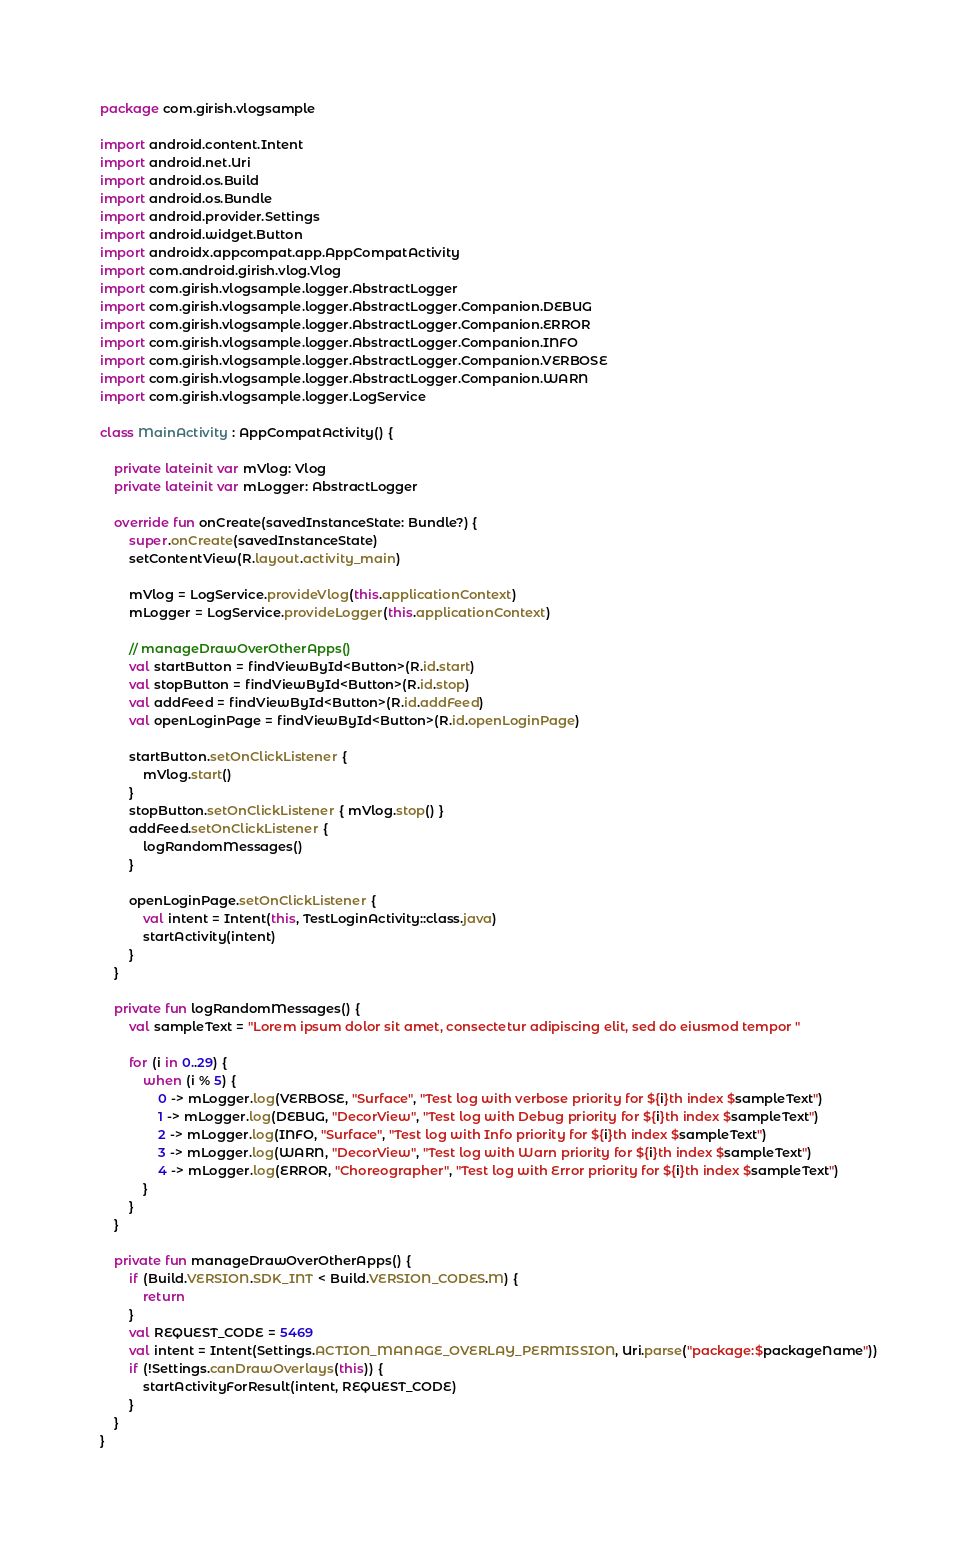<code> <loc_0><loc_0><loc_500><loc_500><_Kotlin_>package com.girish.vlogsample

import android.content.Intent
import android.net.Uri
import android.os.Build
import android.os.Bundle
import android.provider.Settings
import android.widget.Button
import androidx.appcompat.app.AppCompatActivity
import com.android.girish.vlog.Vlog
import com.girish.vlogsample.logger.AbstractLogger
import com.girish.vlogsample.logger.AbstractLogger.Companion.DEBUG
import com.girish.vlogsample.logger.AbstractLogger.Companion.ERROR
import com.girish.vlogsample.logger.AbstractLogger.Companion.INFO
import com.girish.vlogsample.logger.AbstractLogger.Companion.VERBOSE
import com.girish.vlogsample.logger.AbstractLogger.Companion.WARN
import com.girish.vlogsample.logger.LogService

class MainActivity : AppCompatActivity() {

    private lateinit var mVlog: Vlog
    private lateinit var mLogger: AbstractLogger

    override fun onCreate(savedInstanceState: Bundle?) {
        super.onCreate(savedInstanceState)
        setContentView(R.layout.activity_main)

        mVlog = LogService.provideVlog(this.applicationContext)
        mLogger = LogService.provideLogger(this.applicationContext)

        // manageDrawOverOtherApps()
        val startButton = findViewById<Button>(R.id.start)
        val stopButton = findViewById<Button>(R.id.stop)
        val addFeed = findViewById<Button>(R.id.addFeed)
        val openLoginPage = findViewById<Button>(R.id.openLoginPage)

        startButton.setOnClickListener {
            mVlog.start()
        }
        stopButton.setOnClickListener { mVlog.stop() }
        addFeed.setOnClickListener {
            logRandomMessages()
        }

        openLoginPage.setOnClickListener {
            val intent = Intent(this, TestLoginActivity::class.java)
            startActivity(intent)
        }
    }

    private fun logRandomMessages() {
        val sampleText = "Lorem ipsum dolor sit amet, consectetur adipiscing elit, sed do eiusmod tempor "

        for (i in 0..29) {
            when (i % 5) {
                0 -> mLogger.log(VERBOSE, "Surface", "Test log with verbose priority for ${i}th index $sampleText")
                1 -> mLogger.log(DEBUG, "DecorView", "Test log with Debug priority for ${i}th index $sampleText")
                2 -> mLogger.log(INFO, "Surface", "Test log with Info priority for ${i}th index $sampleText")
                3 -> mLogger.log(WARN, "DecorView", "Test log with Warn priority for ${i}th index $sampleText")
                4 -> mLogger.log(ERROR, "Choreographer", "Test log with Error priority for ${i}th index $sampleText")
            }
        }
    }

    private fun manageDrawOverOtherApps() {
        if (Build.VERSION.SDK_INT < Build.VERSION_CODES.M) {
            return
        }
        val REQUEST_CODE = 5469
        val intent = Intent(Settings.ACTION_MANAGE_OVERLAY_PERMISSION, Uri.parse("package:$packageName"))
        if (!Settings.canDrawOverlays(this)) {
            startActivityForResult(intent, REQUEST_CODE)
        }
    }
}
</code> 